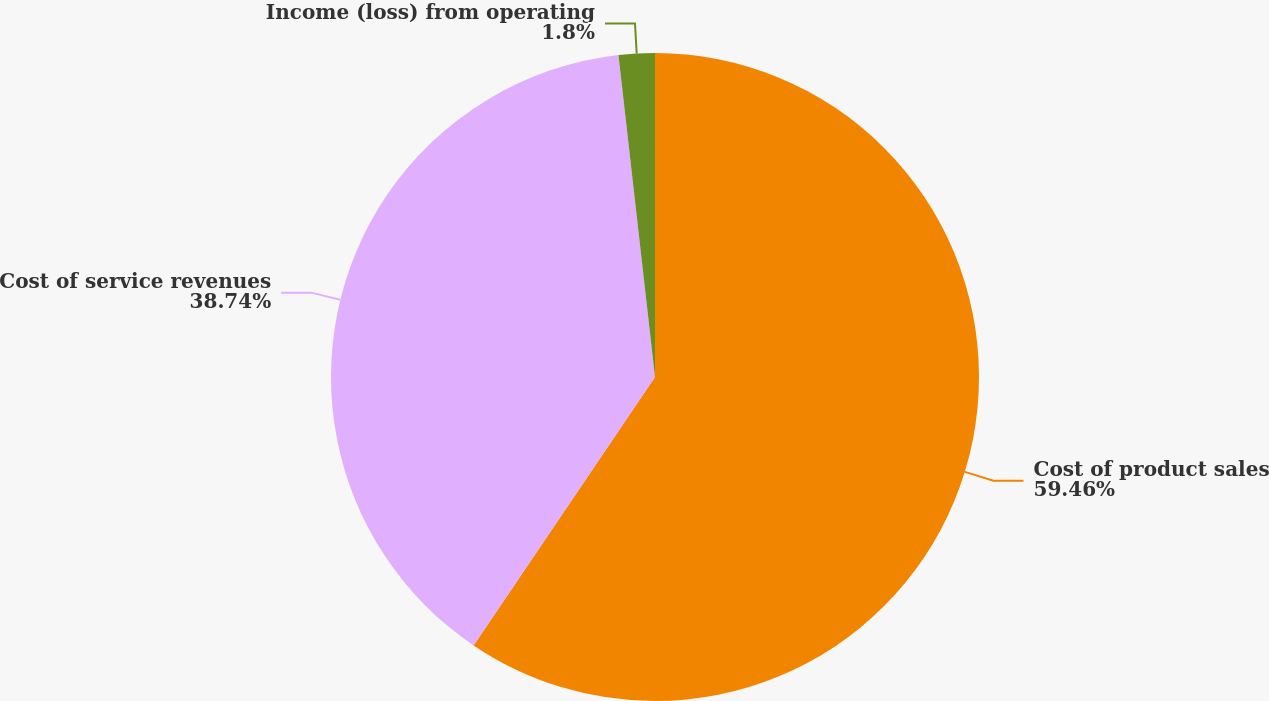<chart> <loc_0><loc_0><loc_500><loc_500><pie_chart><fcel>Cost of product sales<fcel>Cost of service revenues<fcel>Income (loss) from operating<nl><fcel>59.46%<fcel>38.74%<fcel>1.8%<nl></chart> 